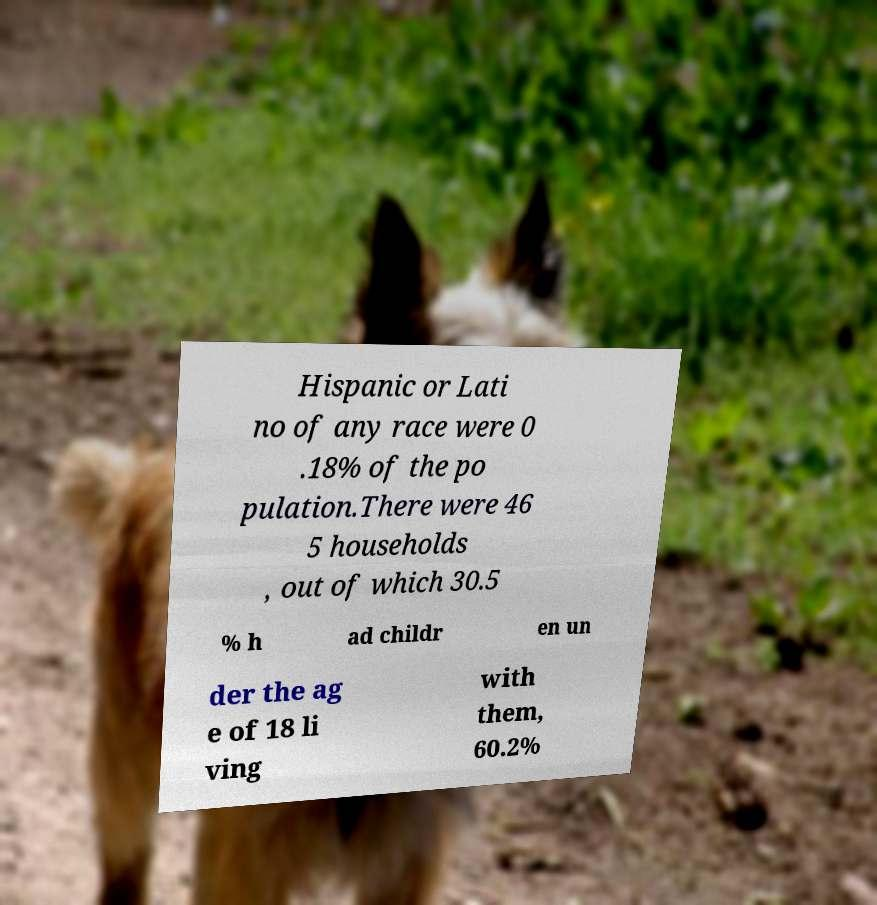I need the written content from this picture converted into text. Can you do that? Hispanic or Lati no of any race were 0 .18% of the po pulation.There were 46 5 households , out of which 30.5 % h ad childr en un der the ag e of 18 li ving with them, 60.2% 